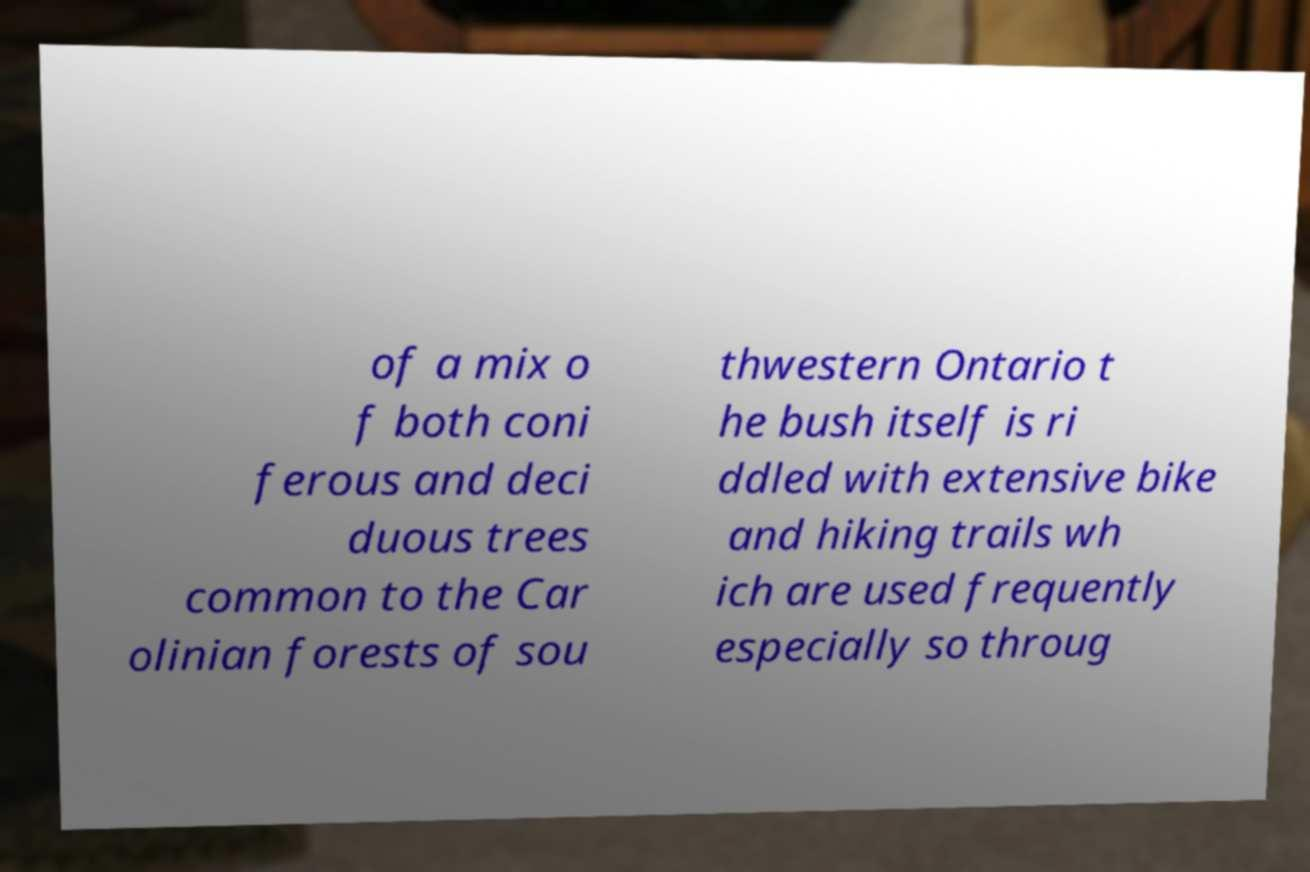Could you extract and type out the text from this image? of a mix o f both coni ferous and deci duous trees common to the Car olinian forests of sou thwestern Ontario t he bush itself is ri ddled with extensive bike and hiking trails wh ich are used frequently especially so throug 